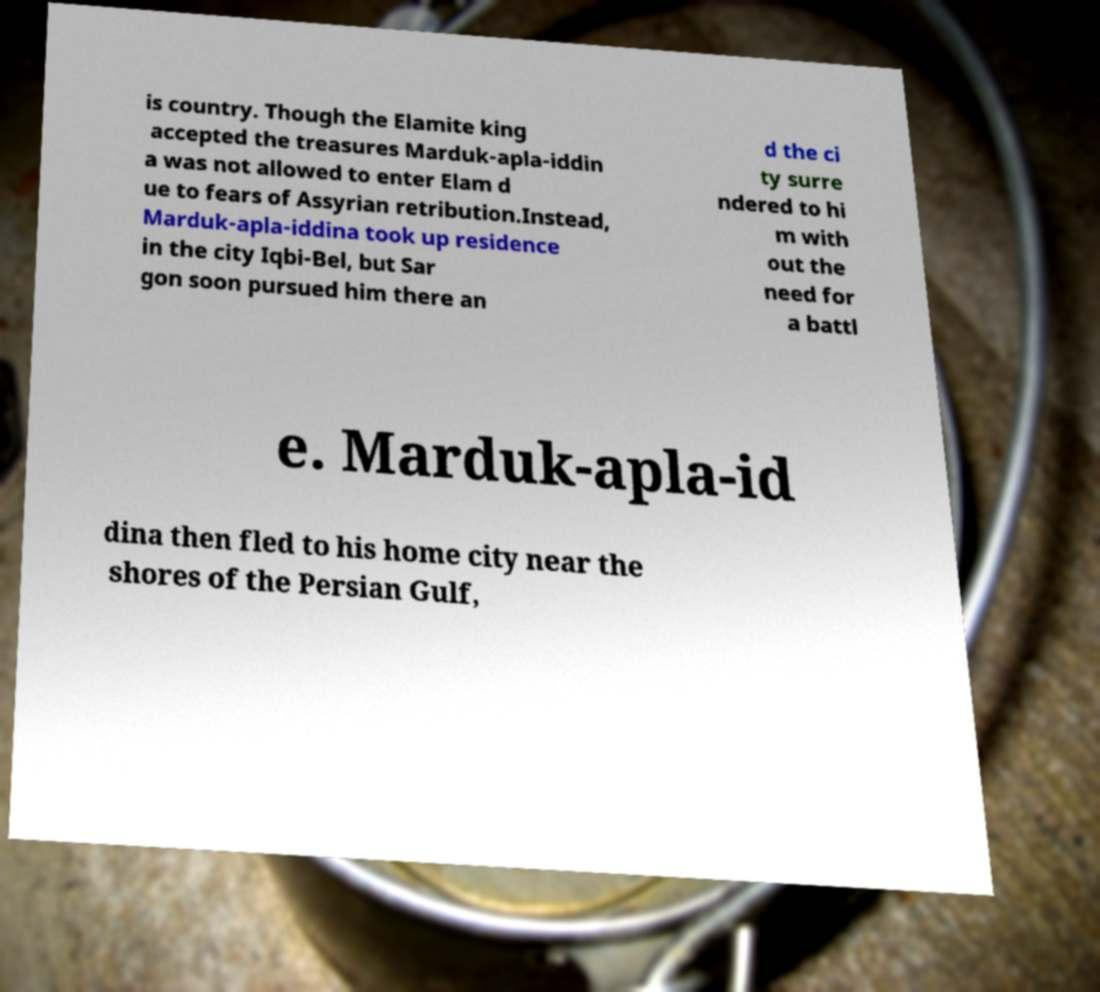Please read and relay the text visible in this image. What does it say? is country. Though the Elamite king accepted the treasures Marduk-apla-iddin a was not allowed to enter Elam d ue to fears of Assyrian retribution.Instead, Marduk-apla-iddina took up residence in the city Iqbi-Bel, but Sar gon soon pursued him there an d the ci ty surre ndered to hi m with out the need for a battl e. Marduk-apla-id dina then fled to his home city near the shores of the Persian Gulf, 